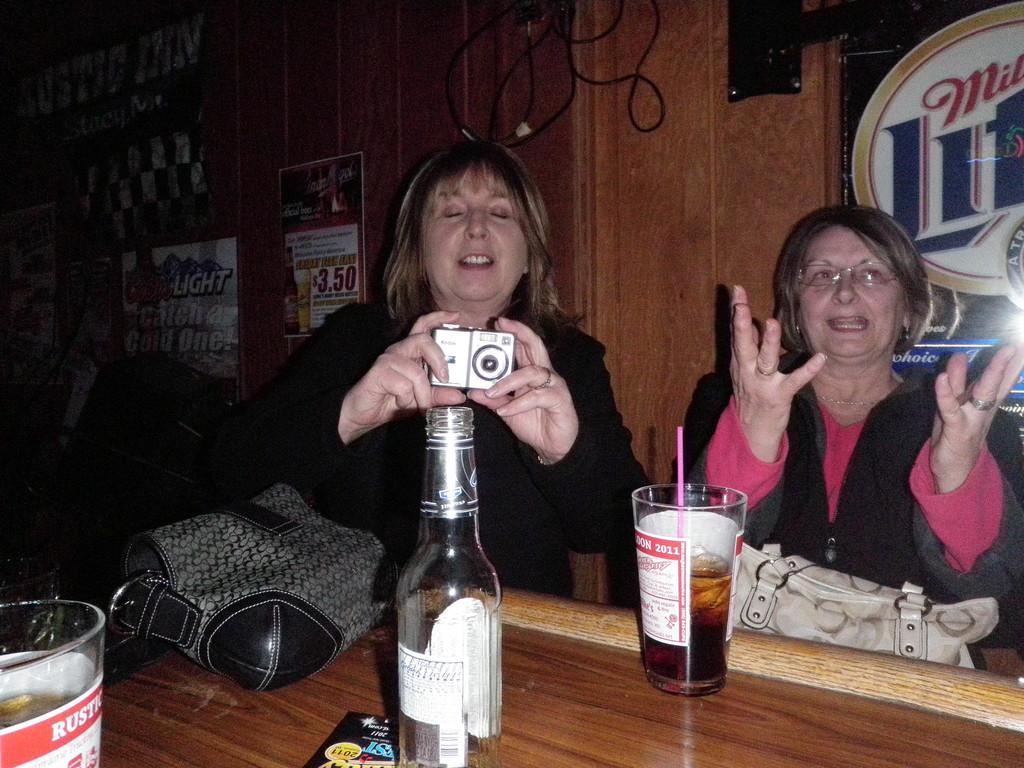How many women are in the image? There are two women in the image. What are the women doing in the image? The women are sitting in the image. What is located in front of the women? There is a table in front of the women. What items can be seen on the table? There is a wine bottle and a glass on the table. Who is holding a camera in the image? A lady is holding a camera in the image. What type of battle is taking place in the image? There is no battle present in the image; it features two women sitting at a table with a wine bottle and a glass. What kind of oatmeal can be seen in the image? There is no oatmeal present in the image. 